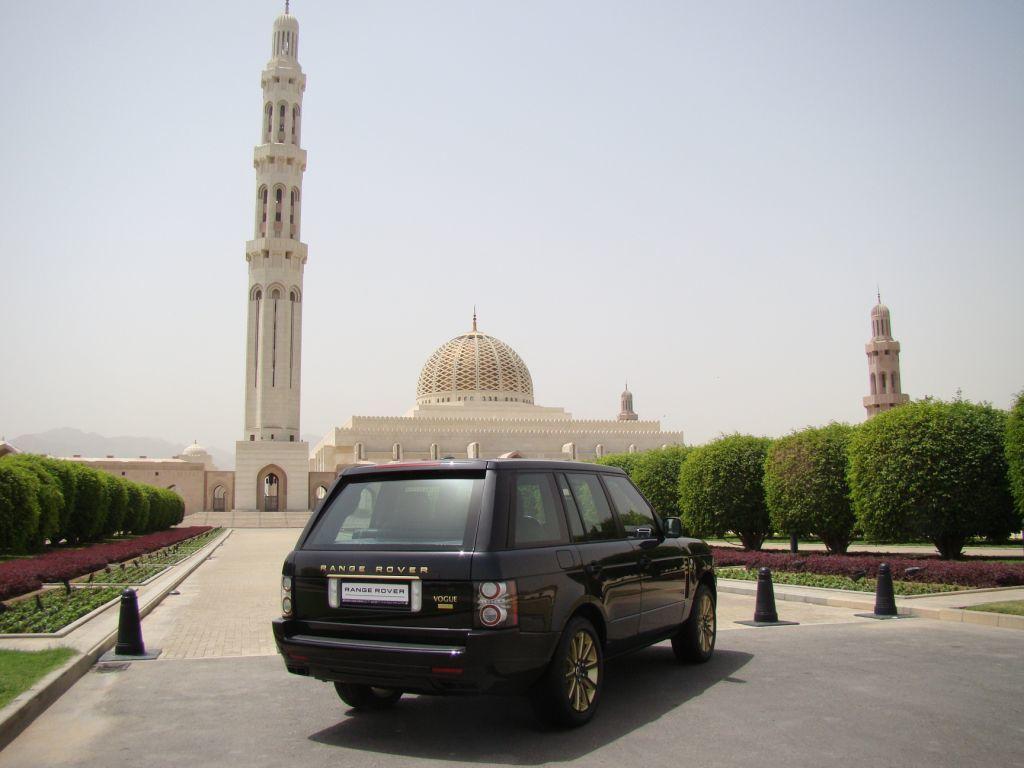What is printed to the right of the licence plate?
Give a very brief answer. Unanswerable. What is the make of the vehicle?
Offer a very short reply. Range rover. 